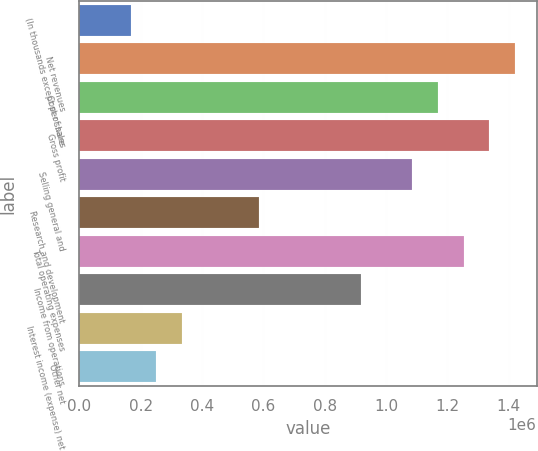<chart> <loc_0><loc_0><loc_500><loc_500><bar_chart><fcel>(In thousands except per share<fcel>Net revenues<fcel>Cost of sales<fcel>Gross profit<fcel>Selling general and<fcel>Research and development<fcel>Total operating expenses<fcel>Income from operations<fcel>Interest income (expense) net<fcel>Other net<nl><fcel>167081<fcel>1.42017e+06<fcel>1.16956e+06<fcel>1.33663e+06<fcel>1.08602e+06<fcel>584778<fcel>1.25309e+06<fcel>918937<fcel>334160<fcel>250620<nl></chart> 